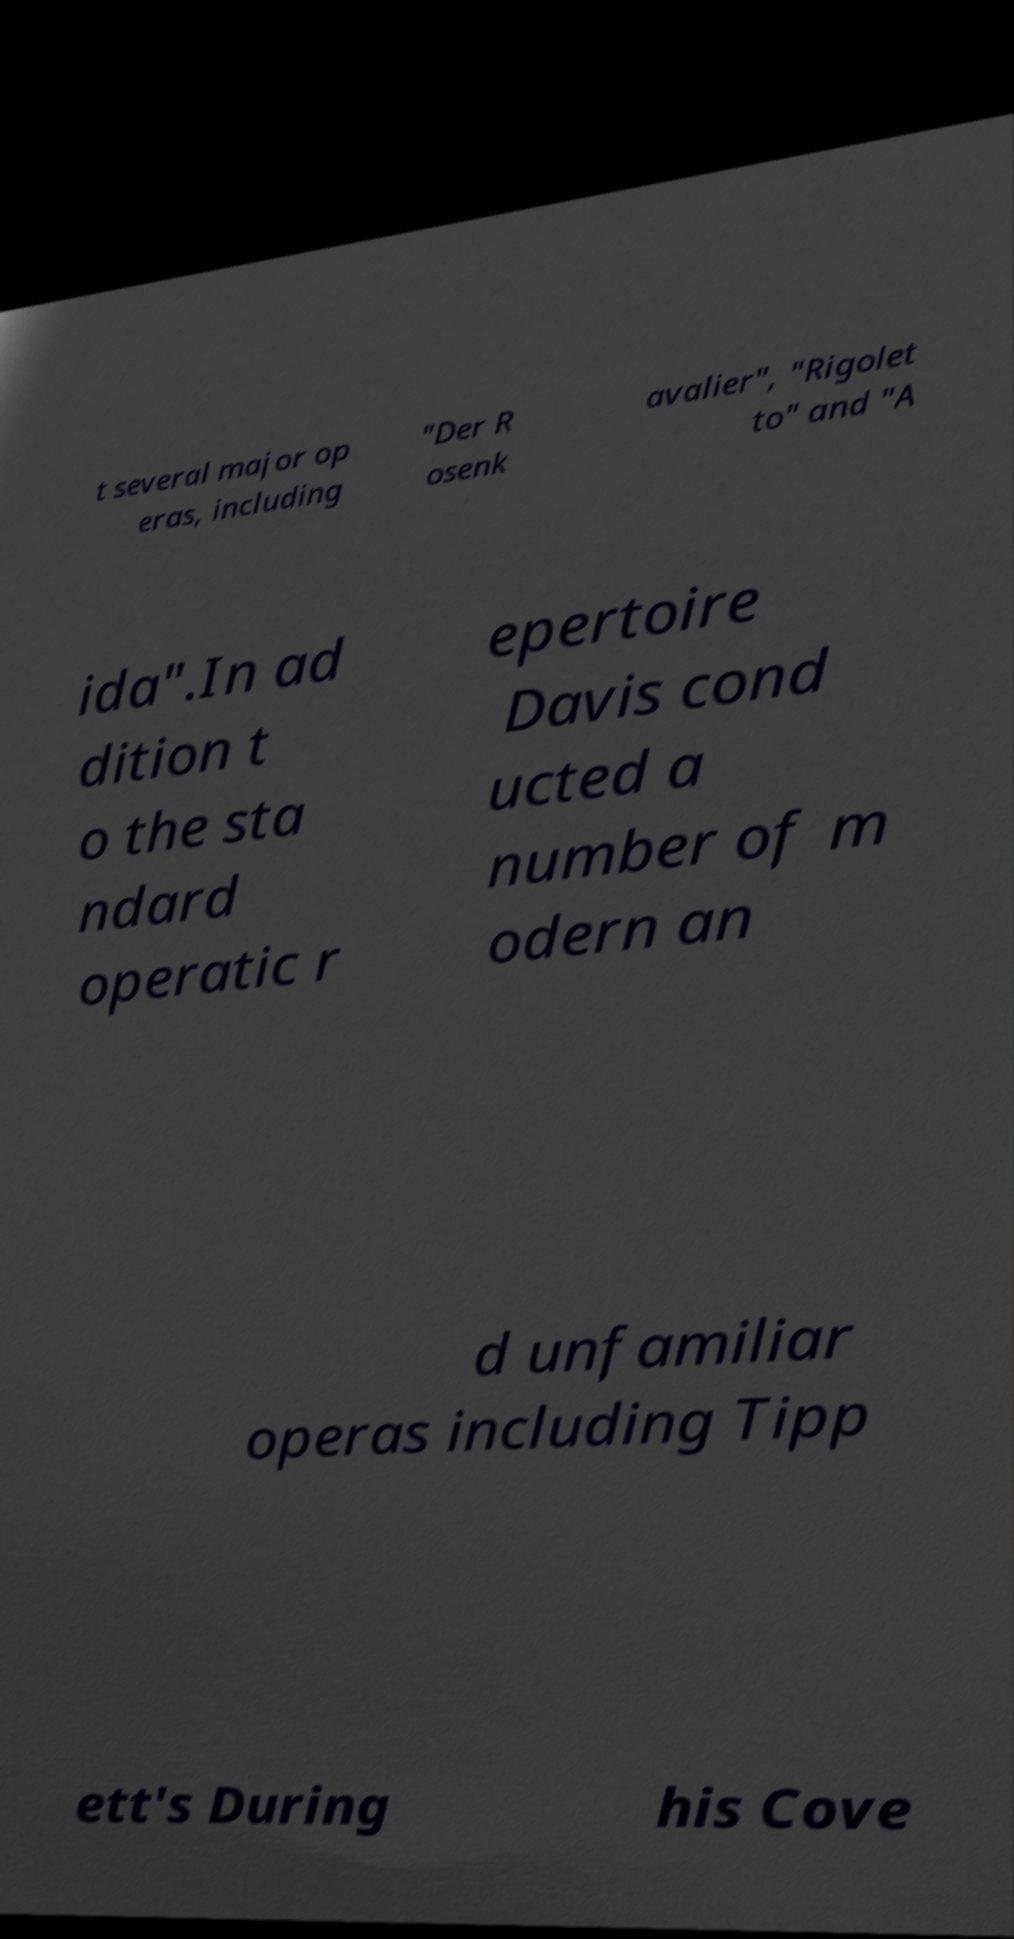Please identify and transcribe the text found in this image. t several major op eras, including "Der R osenk avalier", "Rigolet to" and "A ida".In ad dition t o the sta ndard operatic r epertoire Davis cond ucted a number of m odern an d unfamiliar operas including Tipp ett's During his Cove 